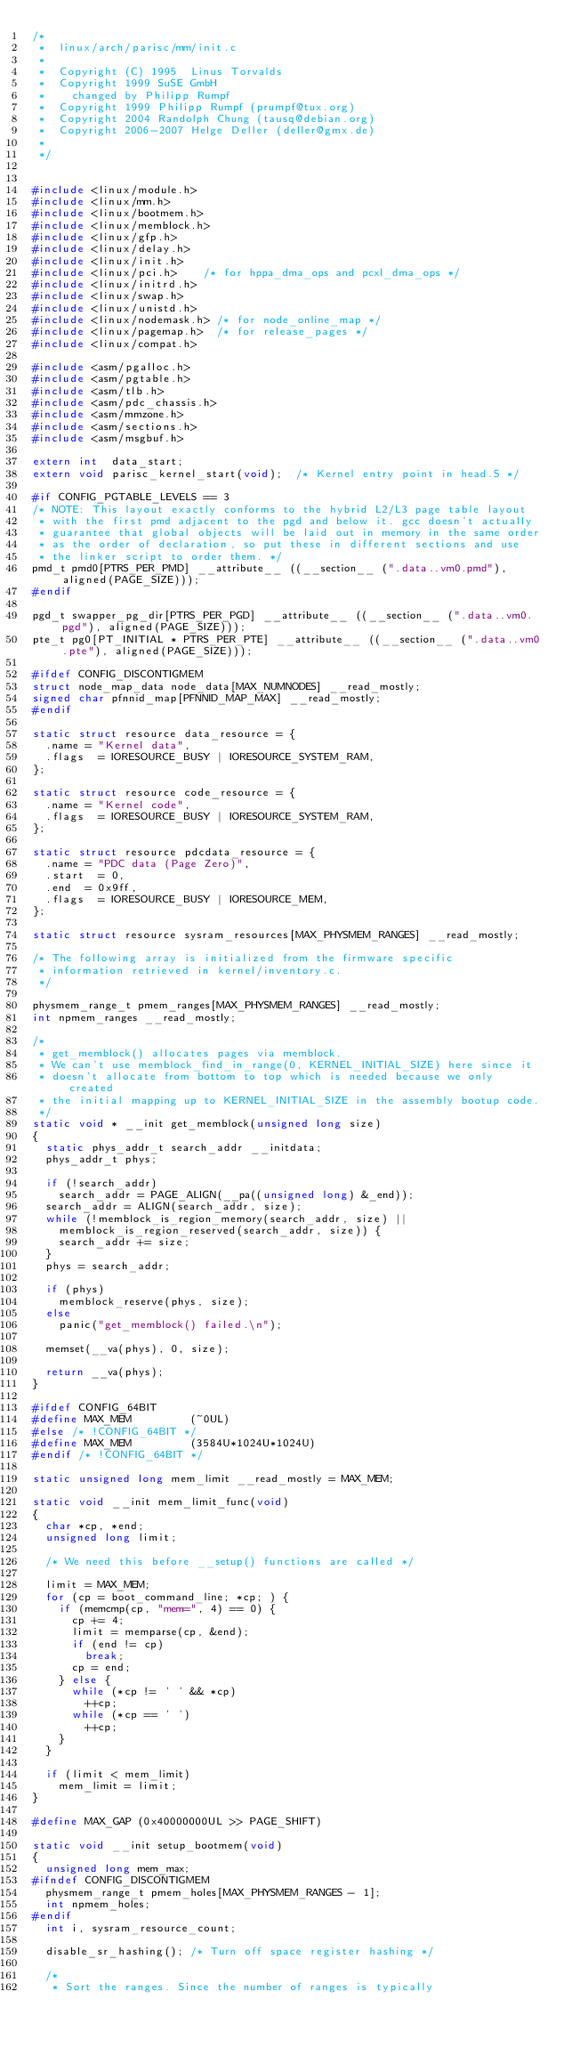<code> <loc_0><loc_0><loc_500><loc_500><_C_>/*
 *  linux/arch/parisc/mm/init.c
 *
 *  Copyright (C) 1995	Linus Torvalds
 *  Copyright 1999 SuSE GmbH
 *    changed by Philipp Rumpf
 *  Copyright 1999 Philipp Rumpf (prumpf@tux.org)
 *  Copyright 2004 Randolph Chung (tausq@debian.org)
 *  Copyright 2006-2007 Helge Deller (deller@gmx.de)
 *
 */


#include <linux/module.h>
#include <linux/mm.h>
#include <linux/bootmem.h>
#include <linux/memblock.h>
#include <linux/gfp.h>
#include <linux/delay.h>
#include <linux/init.h>
#include <linux/pci.h>		/* for hppa_dma_ops and pcxl_dma_ops */
#include <linux/initrd.h>
#include <linux/swap.h>
#include <linux/unistd.h>
#include <linux/nodemask.h>	/* for node_online_map */
#include <linux/pagemap.h>	/* for release_pages */
#include <linux/compat.h>

#include <asm/pgalloc.h>
#include <asm/pgtable.h>
#include <asm/tlb.h>
#include <asm/pdc_chassis.h>
#include <asm/mmzone.h>
#include <asm/sections.h>
#include <asm/msgbuf.h>

extern int  data_start;
extern void parisc_kernel_start(void);	/* Kernel entry point in head.S */

#if CONFIG_PGTABLE_LEVELS == 3
/* NOTE: This layout exactly conforms to the hybrid L2/L3 page table layout
 * with the first pmd adjacent to the pgd and below it. gcc doesn't actually
 * guarantee that global objects will be laid out in memory in the same order
 * as the order of declaration, so put these in different sections and use
 * the linker script to order them. */
pmd_t pmd0[PTRS_PER_PMD] __attribute__ ((__section__ (".data..vm0.pmd"), aligned(PAGE_SIZE)));
#endif

pgd_t swapper_pg_dir[PTRS_PER_PGD] __attribute__ ((__section__ (".data..vm0.pgd"), aligned(PAGE_SIZE)));
pte_t pg0[PT_INITIAL * PTRS_PER_PTE] __attribute__ ((__section__ (".data..vm0.pte"), aligned(PAGE_SIZE)));

#ifdef CONFIG_DISCONTIGMEM
struct node_map_data node_data[MAX_NUMNODES] __read_mostly;
signed char pfnnid_map[PFNNID_MAP_MAX] __read_mostly;
#endif

static struct resource data_resource = {
	.name	= "Kernel data",
	.flags	= IORESOURCE_BUSY | IORESOURCE_SYSTEM_RAM,
};

static struct resource code_resource = {
	.name	= "Kernel code",
	.flags	= IORESOURCE_BUSY | IORESOURCE_SYSTEM_RAM,
};

static struct resource pdcdata_resource = {
	.name	= "PDC data (Page Zero)",
	.start	= 0,
	.end	= 0x9ff,
	.flags	= IORESOURCE_BUSY | IORESOURCE_MEM,
};

static struct resource sysram_resources[MAX_PHYSMEM_RANGES] __read_mostly;

/* The following array is initialized from the firmware specific
 * information retrieved in kernel/inventory.c.
 */

physmem_range_t pmem_ranges[MAX_PHYSMEM_RANGES] __read_mostly;
int npmem_ranges __read_mostly;

/*
 * get_memblock() allocates pages via memblock.
 * We can't use memblock_find_in_range(0, KERNEL_INITIAL_SIZE) here since it
 * doesn't allocate from bottom to top which is needed because we only created
 * the initial mapping up to KERNEL_INITIAL_SIZE in the assembly bootup code.
 */
static void * __init get_memblock(unsigned long size)
{
	static phys_addr_t search_addr __initdata;
	phys_addr_t phys;

	if (!search_addr)
		search_addr = PAGE_ALIGN(__pa((unsigned long) &_end));
	search_addr = ALIGN(search_addr, size);
	while (!memblock_is_region_memory(search_addr, size) ||
		memblock_is_region_reserved(search_addr, size)) {
		search_addr += size;
	}
	phys = search_addr;

	if (phys)
		memblock_reserve(phys, size);
	else
		panic("get_memblock() failed.\n");

	memset(__va(phys), 0, size);

	return __va(phys);
}

#ifdef CONFIG_64BIT
#define MAX_MEM         (~0UL)
#else /* !CONFIG_64BIT */
#define MAX_MEM         (3584U*1024U*1024U)
#endif /* !CONFIG_64BIT */

static unsigned long mem_limit __read_mostly = MAX_MEM;

static void __init mem_limit_func(void)
{
	char *cp, *end;
	unsigned long limit;

	/* We need this before __setup() functions are called */

	limit = MAX_MEM;
	for (cp = boot_command_line; *cp; ) {
		if (memcmp(cp, "mem=", 4) == 0) {
			cp += 4;
			limit = memparse(cp, &end);
			if (end != cp)
				break;
			cp = end;
		} else {
			while (*cp != ' ' && *cp)
				++cp;
			while (*cp == ' ')
				++cp;
		}
	}

	if (limit < mem_limit)
		mem_limit = limit;
}

#define MAX_GAP (0x40000000UL >> PAGE_SHIFT)

static void __init setup_bootmem(void)
{
	unsigned long mem_max;
#ifndef CONFIG_DISCONTIGMEM
	physmem_range_t pmem_holes[MAX_PHYSMEM_RANGES - 1];
	int npmem_holes;
#endif
	int i, sysram_resource_count;

	disable_sr_hashing(); /* Turn off space register hashing */

	/*
	 * Sort the ranges. Since the number of ranges is typically</code> 